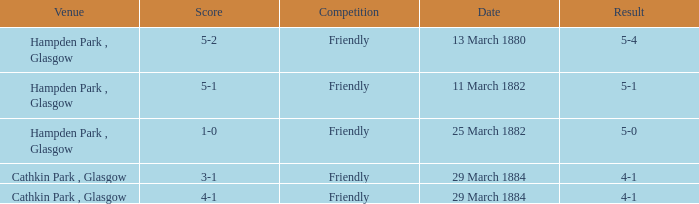Which item has a score of 5-1? 5-1. 